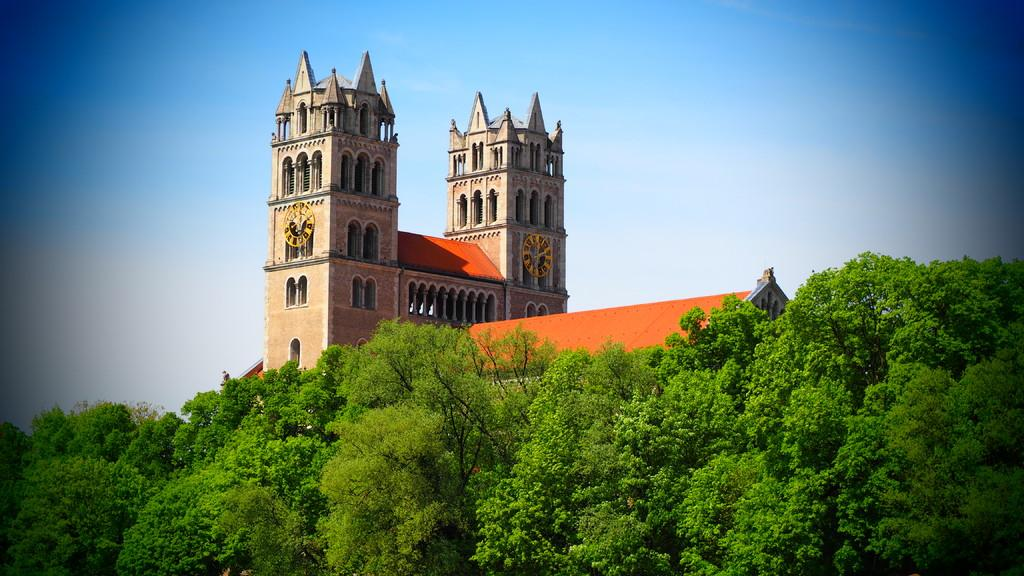What is the main structure in the center of the image? There is a building in the center of the image. What else can be seen in the center of the image? There are blocks and a roof in the center of the image. What type of vegetation is present at the bottom of the image? Trees are present at the bottom of the image. What is visible at the top of the image? The sky is visible at the top of the image. What type of humor is being taught in the building in the image? There is no indication of humor or teaching in the image; it simply shows a building, blocks, a roof, trees, and the sky. 